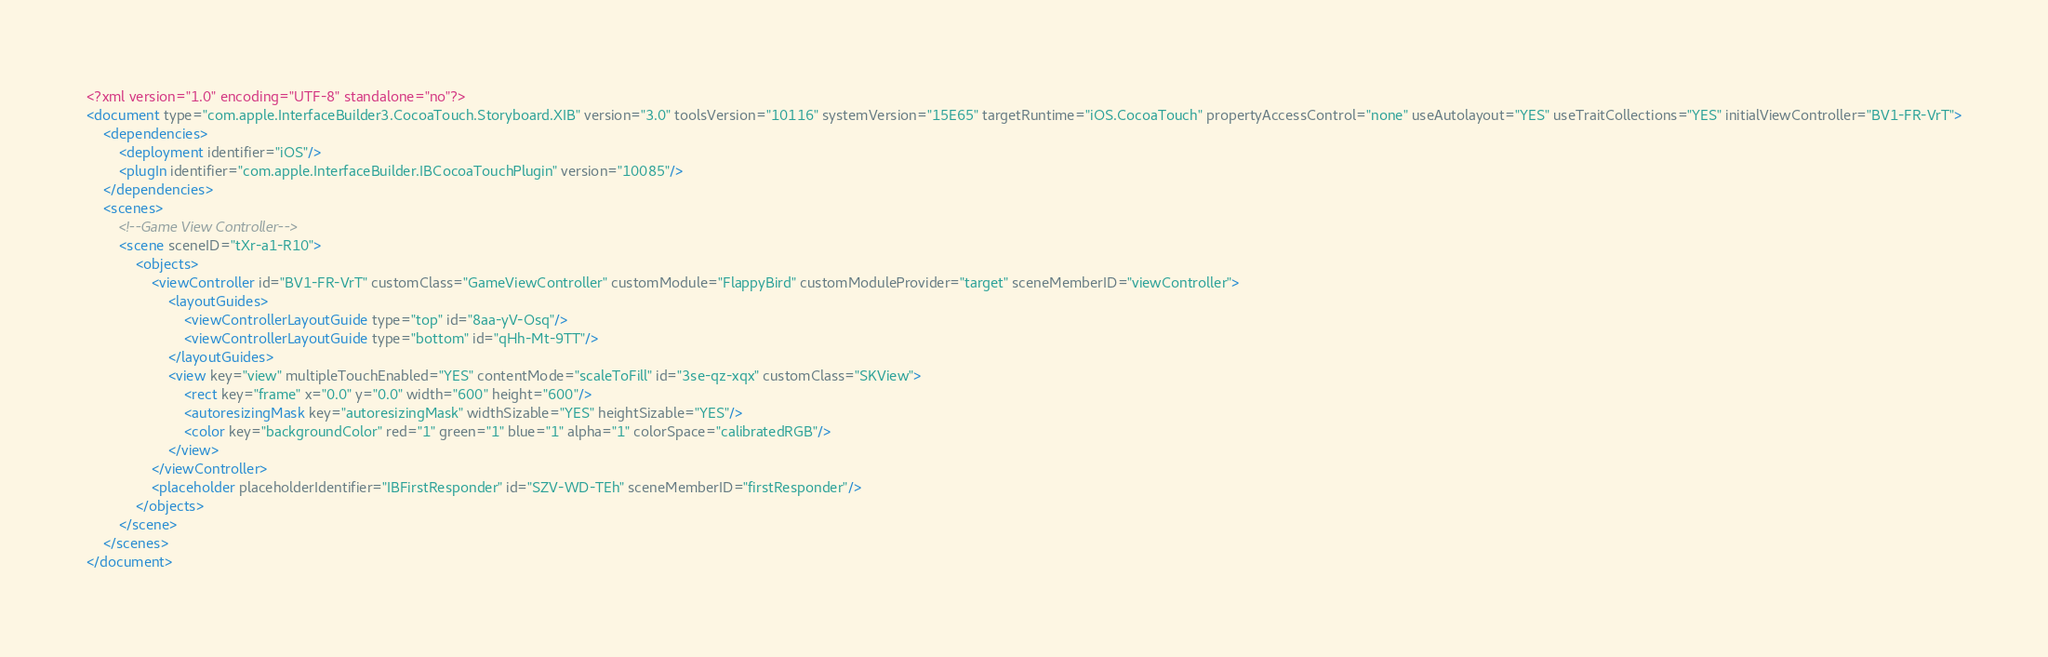Convert code to text. <code><loc_0><loc_0><loc_500><loc_500><_XML_><?xml version="1.0" encoding="UTF-8" standalone="no"?>
<document type="com.apple.InterfaceBuilder3.CocoaTouch.Storyboard.XIB" version="3.0" toolsVersion="10116" systemVersion="15E65" targetRuntime="iOS.CocoaTouch" propertyAccessControl="none" useAutolayout="YES" useTraitCollections="YES" initialViewController="BV1-FR-VrT">
    <dependencies>
        <deployment identifier="iOS"/>
        <plugIn identifier="com.apple.InterfaceBuilder.IBCocoaTouchPlugin" version="10085"/>
    </dependencies>
    <scenes>
        <!--Game View Controller-->
        <scene sceneID="tXr-a1-R10">
            <objects>
                <viewController id="BV1-FR-VrT" customClass="GameViewController" customModule="FlappyBird" customModuleProvider="target" sceneMemberID="viewController">
                    <layoutGuides>
                        <viewControllerLayoutGuide type="top" id="8aa-yV-Osq"/>
                        <viewControllerLayoutGuide type="bottom" id="qHh-Mt-9TT"/>
                    </layoutGuides>
                    <view key="view" multipleTouchEnabled="YES" contentMode="scaleToFill" id="3se-qz-xqx" customClass="SKView">
                        <rect key="frame" x="0.0" y="0.0" width="600" height="600"/>
                        <autoresizingMask key="autoresizingMask" widthSizable="YES" heightSizable="YES"/>
                        <color key="backgroundColor" red="1" green="1" blue="1" alpha="1" colorSpace="calibratedRGB"/>
                    </view>
                </viewController>
                <placeholder placeholderIdentifier="IBFirstResponder" id="SZV-WD-TEh" sceneMemberID="firstResponder"/>
            </objects>
        </scene>
    </scenes>
</document>
</code> 